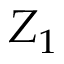Convert formula to latex. <formula><loc_0><loc_0><loc_500><loc_500>Z _ { 1 }</formula> 